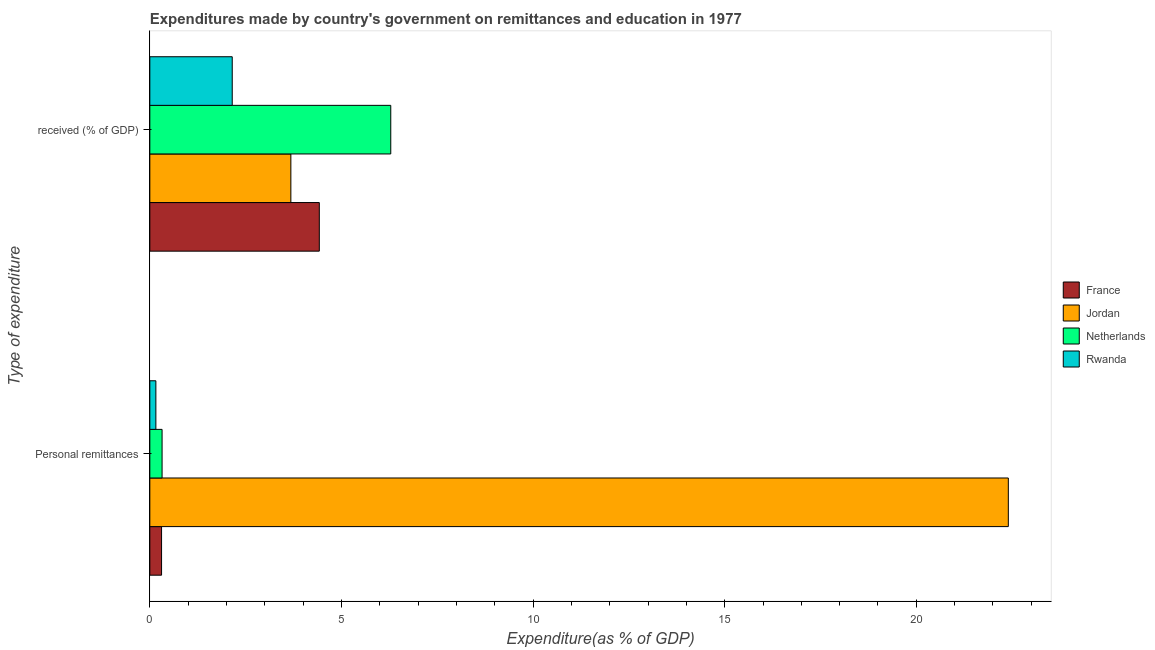How many different coloured bars are there?
Your answer should be very brief. 4. How many groups of bars are there?
Your answer should be very brief. 2. Are the number of bars on each tick of the Y-axis equal?
Make the answer very short. Yes. What is the label of the 1st group of bars from the top?
Keep it short and to the point.  received (% of GDP). What is the expenditure in personal remittances in Netherlands?
Make the answer very short. 0.32. Across all countries, what is the maximum expenditure in personal remittances?
Your answer should be compact. 22.4. Across all countries, what is the minimum expenditure in education?
Make the answer very short. 2.15. In which country was the expenditure in personal remittances minimum?
Provide a short and direct response. Rwanda. What is the total expenditure in education in the graph?
Offer a terse response. 16.54. What is the difference between the expenditure in education in France and that in Rwanda?
Your answer should be compact. 2.27. What is the difference between the expenditure in education in Jordan and the expenditure in personal remittances in Netherlands?
Keep it short and to the point. 3.36. What is the average expenditure in personal remittances per country?
Offer a very short reply. 5.8. What is the difference between the expenditure in education and expenditure in personal remittances in France?
Provide a succinct answer. 4.12. What is the ratio of the expenditure in education in Netherlands to that in Jordan?
Keep it short and to the point. 1.71. Is the expenditure in personal remittances in Rwanda less than that in Jordan?
Provide a succinct answer. Yes. How many countries are there in the graph?
Provide a short and direct response. 4. Does the graph contain any zero values?
Offer a very short reply. No. Does the graph contain grids?
Ensure brevity in your answer.  No. How many legend labels are there?
Ensure brevity in your answer.  4. What is the title of the graph?
Keep it short and to the point. Expenditures made by country's government on remittances and education in 1977. Does "Isle of Man" appear as one of the legend labels in the graph?
Offer a very short reply. No. What is the label or title of the X-axis?
Ensure brevity in your answer.  Expenditure(as % of GDP). What is the label or title of the Y-axis?
Your answer should be compact. Type of expenditure. What is the Expenditure(as % of GDP) in France in Personal remittances?
Give a very brief answer. 0.31. What is the Expenditure(as % of GDP) of Jordan in Personal remittances?
Your answer should be compact. 22.4. What is the Expenditure(as % of GDP) in Netherlands in Personal remittances?
Your answer should be very brief. 0.32. What is the Expenditure(as % of GDP) in Rwanda in Personal remittances?
Provide a short and direct response. 0.16. What is the Expenditure(as % of GDP) in France in  received (% of GDP)?
Ensure brevity in your answer.  4.42. What is the Expenditure(as % of GDP) in Jordan in  received (% of GDP)?
Your response must be concise. 3.68. What is the Expenditure(as % of GDP) in Netherlands in  received (% of GDP)?
Your answer should be compact. 6.29. What is the Expenditure(as % of GDP) of Rwanda in  received (% of GDP)?
Keep it short and to the point. 2.15. Across all Type of expenditure, what is the maximum Expenditure(as % of GDP) of France?
Your answer should be very brief. 4.42. Across all Type of expenditure, what is the maximum Expenditure(as % of GDP) in Jordan?
Make the answer very short. 22.4. Across all Type of expenditure, what is the maximum Expenditure(as % of GDP) in Netherlands?
Offer a very short reply. 6.29. Across all Type of expenditure, what is the maximum Expenditure(as % of GDP) in Rwanda?
Provide a succinct answer. 2.15. Across all Type of expenditure, what is the minimum Expenditure(as % of GDP) in France?
Ensure brevity in your answer.  0.31. Across all Type of expenditure, what is the minimum Expenditure(as % of GDP) of Jordan?
Keep it short and to the point. 3.68. Across all Type of expenditure, what is the minimum Expenditure(as % of GDP) in Netherlands?
Provide a succinct answer. 0.32. Across all Type of expenditure, what is the minimum Expenditure(as % of GDP) in Rwanda?
Provide a short and direct response. 0.16. What is the total Expenditure(as % of GDP) in France in the graph?
Your answer should be compact. 4.73. What is the total Expenditure(as % of GDP) of Jordan in the graph?
Give a very brief answer. 26.08. What is the total Expenditure(as % of GDP) of Netherlands in the graph?
Offer a terse response. 6.61. What is the total Expenditure(as % of GDP) in Rwanda in the graph?
Keep it short and to the point. 2.31. What is the difference between the Expenditure(as % of GDP) of France in Personal remittances and that in  received (% of GDP)?
Your answer should be very brief. -4.12. What is the difference between the Expenditure(as % of GDP) of Jordan in Personal remittances and that in  received (% of GDP)?
Make the answer very short. 18.72. What is the difference between the Expenditure(as % of GDP) in Netherlands in Personal remittances and that in  received (% of GDP)?
Ensure brevity in your answer.  -5.97. What is the difference between the Expenditure(as % of GDP) of Rwanda in Personal remittances and that in  received (% of GDP)?
Give a very brief answer. -1.99. What is the difference between the Expenditure(as % of GDP) of France in Personal remittances and the Expenditure(as % of GDP) of Jordan in  received (% of GDP)?
Provide a succinct answer. -3.37. What is the difference between the Expenditure(as % of GDP) of France in Personal remittances and the Expenditure(as % of GDP) of Netherlands in  received (% of GDP)?
Make the answer very short. -5.98. What is the difference between the Expenditure(as % of GDP) in France in Personal remittances and the Expenditure(as % of GDP) in Rwanda in  received (% of GDP)?
Your answer should be compact. -1.84. What is the difference between the Expenditure(as % of GDP) in Jordan in Personal remittances and the Expenditure(as % of GDP) in Netherlands in  received (% of GDP)?
Provide a succinct answer. 16.11. What is the difference between the Expenditure(as % of GDP) of Jordan in Personal remittances and the Expenditure(as % of GDP) of Rwanda in  received (% of GDP)?
Provide a succinct answer. 20.25. What is the difference between the Expenditure(as % of GDP) in Netherlands in Personal remittances and the Expenditure(as % of GDP) in Rwanda in  received (% of GDP)?
Make the answer very short. -1.83. What is the average Expenditure(as % of GDP) in France per Type of expenditure?
Give a very brief answer. 2.36. What is the average Expenditure(as % of GDP) of Jordan per Type of expenditure?
Give a very brief answer. 13.04. What is the average Expenditure(as % of GDP) in Netherlands per Type of expenditure?
Make the answer very short. 3.3. What is the average Expenditure(as % of GDP) of Rwanda per Type of expenditure?
Keep it short and to the point. 1.15. What is the difference between the Expenditure(as % of GDP) of France and Expenditure(as % of GDP) of Jordan in Personal remittances?
Ensure brevity in your answer.  -22.09. What is the difference between the Expenditure(as % of GDP) in France and Expenditure(as % of GDP) in Netherlands in Personal remittances?
Provide a short and direct response. -0.01. What is the difference between the Expenditure(as % of GDP) in France and Expenditure(as % of GDP) in Rwanda in Personal remittances?
Your response must be concise. 0.15. What is the difference between the Expenditure(as % of GDP) in Jordan and Expenditure(as % of GDP) in Netherlands in Personal remittances?
Provide a short and direct response. 22.08. What is the difference between the Expenditure(as % of GDP) of Jordan and Expenditure(as % of GDP) of Rwanda in Personal remittances?
Provide a succinct answer. 22.24. What is the difference between the Expenditure(as % of GDP) of Netherlands and Expenditure(as % of GDP) of Rwanda in Personal remittances?
Make the answer very short. 0.16. What is the difference between the Expenditure(as % of GDP) in France and Expenditure(as % of GDP) in Jordan in  received (% of GDP)?
Your answer should be very brief. 0.74. What is the difference between the Expenditure(as % of GDP) of France and Expenditure(as % of GDP) of Netherlands in  received (% of GDP)?
Ensure brevity in your answer.  -1.86. What is the difference between the Expenditure(as % of GDP) of France and Expenditure(as % of GDP) of Rwanda in  received (% of GDP)?
Keep it short and to the point. 2.27. What is the difference between the Expenditure(as % of GDP) of Jordan and Expenditure(as % of GDP) of Netherlands in  received (% of GDP)?
Keep it short and to the point. -2.61. What is the difference between the Expenditure(as % of GDP) in Jordan and Expenditure(as % of GDP) in Rwanda in  received (% of GDP)?
Offer a terse response. 1.53. What is the difference between the Expenditure(as % of GDP) in Netherlands and Expenditure(as % of GDP) in Rwanda in  received (% of GDP)?
Your answer should be compact. 4.14. What is the ratio of the Expenditure(as % of GDP) in France in Personal remittances to that in  received (% of GDP)?
Provide a short and direct response. 0.07. What is the ratio of the Expenditure(as % of GDP) in Jordan in Personal remittances to that in  received (% of GDP)?
Provide a short and direct response. 6.09. What is the ratio of the Expenditure(as % of GDP) in Netherlands in Personal remittances to that in  received (% of GDP)?
Ensure brevity in your answer.  0.05. What is the ratio of the Expenditure(as % of GDP) of Rwanda in Personal remittances to that in  received (% of GDP)?
Make the answer very short. 0.07. What is the difference between the highest and the second highest Expenditure(as % of GDP) in France?
Offer a very short reply. 4.12. What is the difference between the highest and the second highest Expenditure(as % of GDP) in Jordan?
Your answer should be compact. 18.72. What is the difference between the highest and the second highest Expenditure(as % of GDP) of Netherlands?
Your answer should be compact. 5.97. What is the difference between the highest and the second highest Expenditure(as % of GDP) in Rwanda?
Give a very brief answer. 1.99. What is the difference between the highest and the lowest Expenditure(as % of GDP) of France?
Your answer should be compact. 4.12. What is the difference between the highest and the lowest Expenditure(as % of GDP) of Jordan?
Provide a succinct answer. 18.72. What is the difference between the highest and the lowest Expenditure(as % of GDP) of Netherlands?
Ensure brevity in your answer.  5.97. What is the difference between the highest and the lowest Expenditure(as % of GDP) in Rwanda?
Make the answer very short. 1.99. 